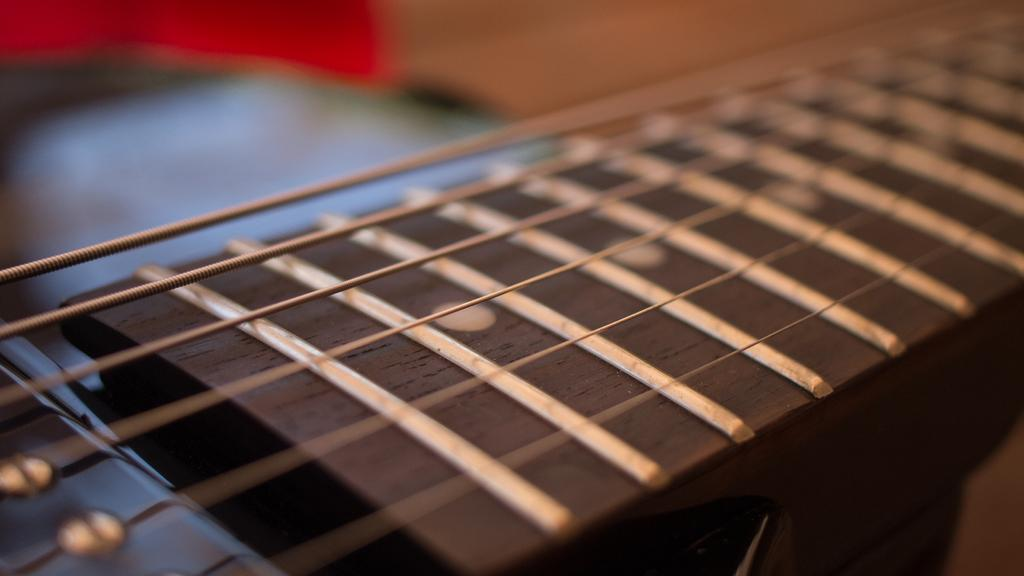What can be seen in the image related to a musical instrument? There are violin strings in the image. Is there a person playing the violin strings while falling from a great height in the image? There is no person or any indication of falling in the image; it only shows violin strings. 